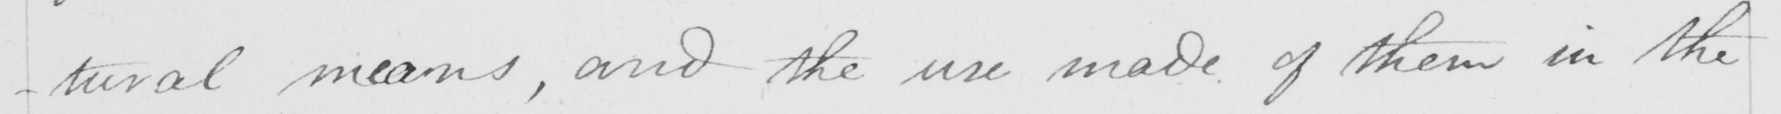Please transcribe the handwritten text in this image. -tural means , and the use made of them in the 